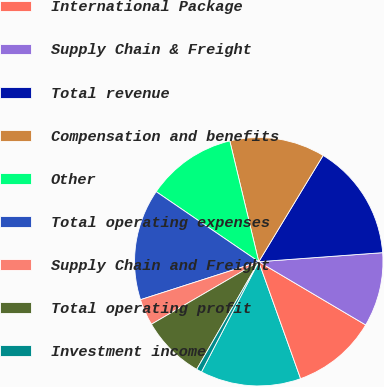<chart> <loc_0><loc_0><loc_500><loc_500><pie_chart><fcel>US Domestic Package<fcel>International Package<fcel>Supply Chain & Freight<fcel>Total revenue<fcel>Compensation and benefits<fcel>Other<fcel>Total operating expenses<fcel>Supply Chain and Freight<fcel>Total operating profit<fcel>Investment income<nl><fcel>13.1%<fcel>11.03%<fcel>9.66%<fcel>15.17%<fcel>12.41%<fcel>11.72%<fcel>14.48%<fcel>3.45%<fcel>8.28%<fcel>0.69%<nl></chart> 